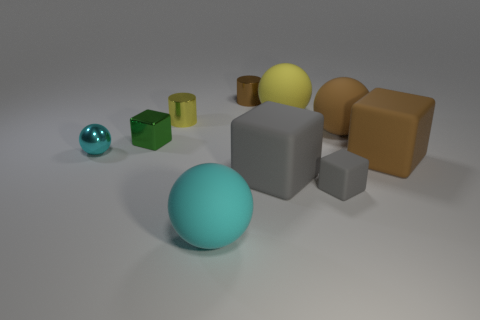Subtract all blocks. How many objects are left? 6 Add 3 tiny yellow metal cylinders. How many tiny yellow metal cylinders exist? 4 Subtract 1 brown cylinders. How many objects are left? 9 Subtract all large objects. Subtract all gray rubber cubes. How many objects are left? 3 Add 4 big brown objects. How many big brown objects are left? 6 